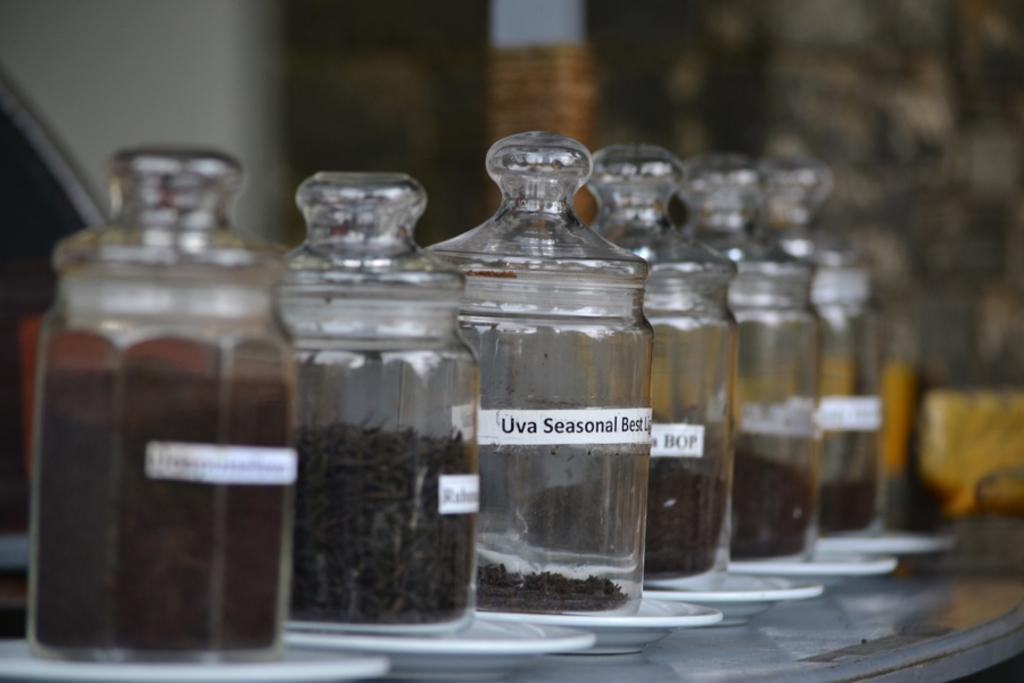<image>
Describe the image concisely. Amongst other jars is one that is labelled uva seasonal best. 